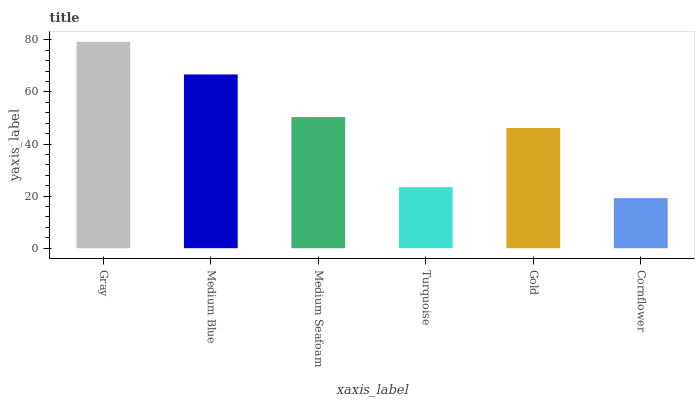Is Cornflower the minimum?
Answer yes or no. Yes. Is Gray the maximum?
Answer yes or no. Yes. Is Medium Blue the minimum?
Answer yes or no. No. Is Medium Blue the maximum?
Answer yes or no. No. Is Gray greater than Medium Blue?
Answer yes or no. Yes. Is Medium Blue less than Gray?
Answer yes or no. Yes. Is Medium Blue greater than Gray?
Answer yes or no. No. Is Gray less than Medium Blue?
Answer yes or no. No. Is Medium Seafoam the high median?
Answer yes or no. Yes. Is Gold the low median?
Answer yes or no. Yes. Is Gray the high median?
Answer yes or no. No. Is Turquoise the low median?
Answer yes or no. No. 